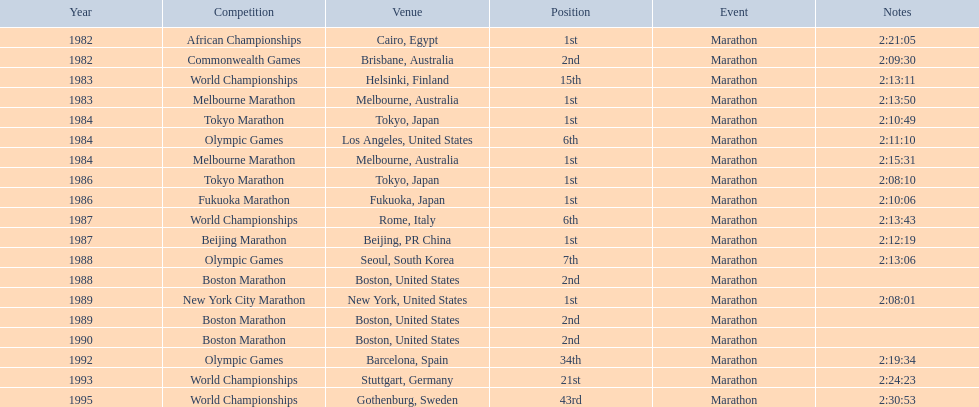Which marathon did juma ikangaa win for the first time? 1982 African Championships. 